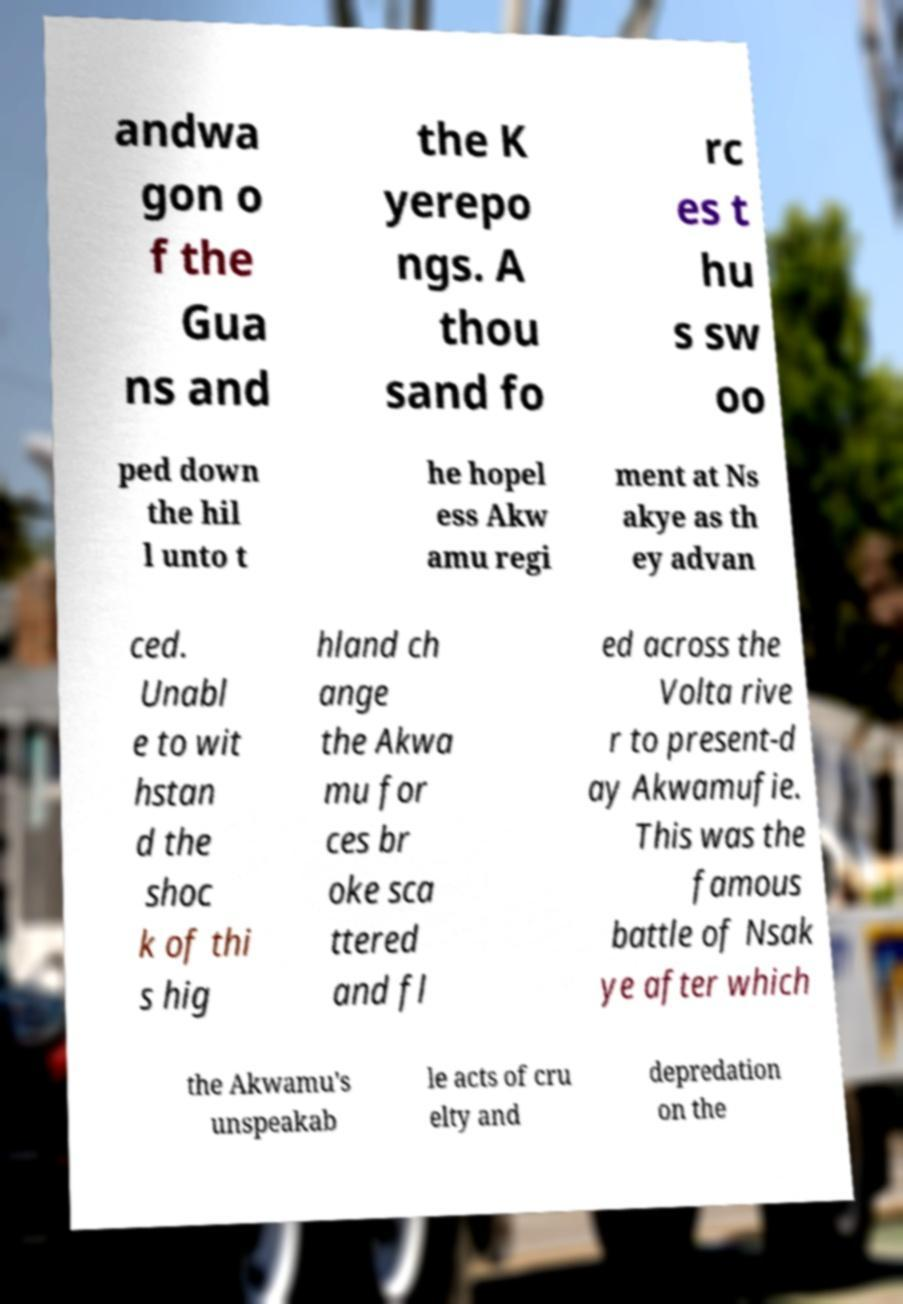For documentation purposes, I need the text within this image transcribed. Could you provide that? andwa gon o f the Gua ns and the K yerepo ngs. A thou sand fo rc es t hu s sw oo ped down the hil l unto t he hopel ess Akw amu regi ment at Ns akye as th ey advan ced. Unabl e to wit hstan d the shoc k of thi s hig hland ch ange the Akwa mu for ces br oke sca ttered and fl ed across the Volta rive r to present-d ay Akwamufie. This was the famous battle of Nsak ye after which the Akwamu's unspeakab le acts of cru elty and depredation on the 